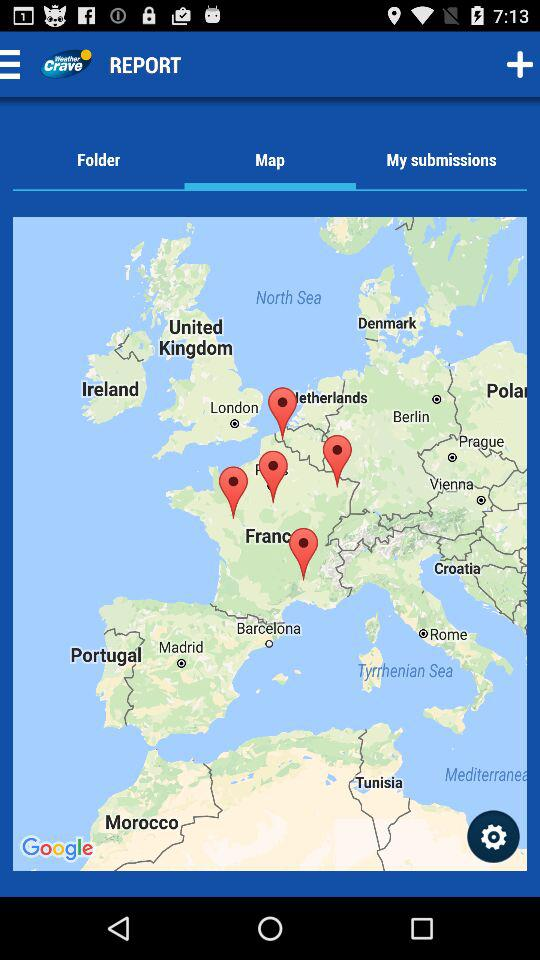What is the application name? The application name is "Weather Crave". 